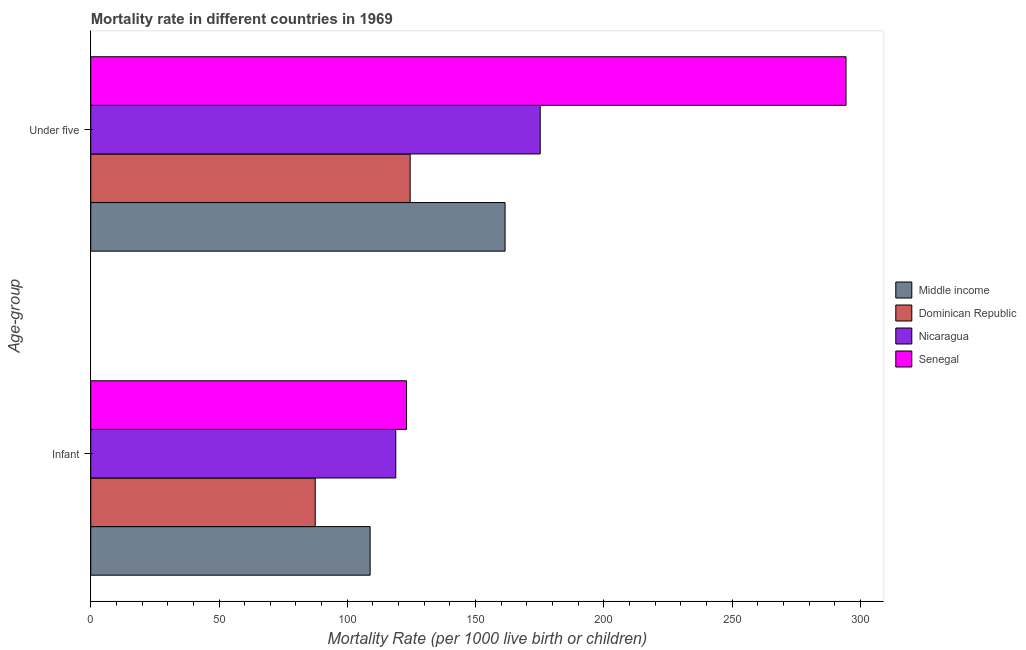How many different coloured bars are there?
Provide a succinct answer. 4. Are the number of bars per tick equal to the number of legend labels?
Make the answer very short. Yes. How many bars are there on the 2nd tick from the top?
Your answer should be compact. 4. What is the label of the 2nd group of bars from the top?
Your answer should be compact. Infant. What is the infant mortality rate in Dominican Republic?
Ensure brevity in your answer.  87.5. Across all countries, what is the maximum under-5 mortality rate?
Your response must be concise. 294.4. Across all countries, what is the minimum under-5 mortality rate?
Your answer should be very brief. 124.5. In which country was the infant mortality rate maximum?
Offer a terse response. Senegal. In which country was the infant mortality rate minimum?
Ensure brevity in your answer.  Dominican Republic. What is the total under-5 mortality rate in the graph?
Ensure brevity in your answer.  755.6. What is the difference between the under-5 mortality rate in Middle income and that in Senegal?
Keep it short and to the point. -132.9. What is the difference between the infant mortality rate in Senegal and the under-5 mortality rate in Middle income?
Your answer should be very brief. -38.4. What is the average infant mortality rate per country?
Make the answer very short. 109.6. What is the difference between the infant mortality rate and under-5 mortality rate in Senegal?
Give a very brief answer. -171.3. What is the ratio of the under-5 mortality rate in Middle income to that in Senegal?
Provide a succinct answer. 0.55. Is the infant mortality rate in Senegal less than that in Middle income?
Provide a short and direct response. No. In how many countries, is the under-5 mortality rate greater than the average under-5 mortality rate taken over all countries?
Make the answer very short. 1. What does the 2nd bar from the top in Infant represents?
Offer a terse response. Nicaragua. What does the 1st bar from the bottom in Infant represents?
Give a very brief answer. Middle income. How many countries are there in the graph?
Keep it short and to the point. 4. Does the graph contain any zero values?
Give a very brief answer. No. Does the graph contain grids?
Provide a short and direct response. No. Where does the legend appear in the graph?
Keep it short and to the point. Center right. How are the legend labels stacked?
Your response must be concise. Vertical. What is the title of the graph?
Make the answer very short. Mortality rate in different countries in 1969. What is the label or title of the X-axis?
Give a very brief answer. Mortality Rate (per 1000 live birth or children). What is the label or title of the Y-axis?
Provide a short and direct response. Age-group. What is the Mortality Rate (per 1000 live birth or children) of Middle income in Infant?
Your answer should be compact. 108.9. What is the Mortality Rate (per 1000 live birth or children) in Dominican Republic in Infant?
Give a very brief answer. 87.5. What is the Mortality Rate (per 1000 live birth or children) of Nicaragua in Infant?
Your answer should be compact. 118.9. What is the Mortality Rate (per 1000 live birth or children) of Senegal in Infant?
Your answer should be very brief. 123.1. What is the Mortality Rate (per 1000 live birth or children) of Middle income in Under five?
Keep it short and to the point. 161.5. What is the Mortality Rate (per 1000 live birth or children) of Dominican Republic in Under five?
Provide a succinct answer. 124.5. What is the Mortality Rate (per 1000 live birth or children) in Nicaragua in Under five?
Make the answer very short. 175.2. What is the Mortality Rate (per 1000 live birth or children) in Senegal in Under five?
Make the answer very short. 294.4. Across all Age-group, what is the maximum Mortality Rate (per 1000 live birth or children) in Middle income?
Offer a very short reply. 161.5. Across all Age-group, what is the maximum Mortality Rate (per 1000 live birth or children) in Dominican Republic?
Ensure brevity in your answer.  124.5. Across all Age-group, what is the maximum Mortality Rate (per 1000 live birth or children) in Nicaragua?
Ensure brevity in your answer.  175.2. Across all Age-group, what is the maximum Mortality Rate (per 1000 live birth or children) in Senegal?
Provide a short and direct response. 294.4. Across all Age-group, what is the minimum Mortality Rate (per 1000 live birth or children) in Middle income?
Your response must be concise. 108.9. Across all Age-group, what is the minimum Mortality Rate (per 1000 live birth or children) in Dominican Republic?
Your response must be concise. 87.5. Across all Age-group, what is the minimum Mortality Rate (per 1000 live birth or children) in Nicaragua?
Your answer should be compact. 118.9. Across all Age-group, what is the minimum Mortality Rate (per 1000 live birth or children) in Senegal?
Keep it short and to the point. 123.1. What is the total Mortality Rate (per 1000 live birth or children) in Middle income in the graph?
Your answer should be very brief. 270.4. What is the total Mortality Rate (per 1000 live birth or children) of Dominican Republic in the graph?
Make the answer very short. 212. What is the total Mortality Rate (per 1000 live birth or children) of Nicaragua in the graph?
Offer a very short reply. 294.1. What is the total Mortality Rate (per 1000 live birth or children) of Senegal in the graph?
Your answer should be compact. 417.5. What is the difference between the Mortality Rate (per 1000 live birth or children) of Middle income in Infant and that in Under five?
Your answer should be compact. -52.6. What is the difference between the Mortality Rate (per 1000 live birth or children) in Dominican Republic in Infant and that in Under five?
Your answer should be compact. -37. What is the difference between the Mortality Rate (per 1000 live birth or children) of Nicaragua in Infant and that in Under five?
Your answer should be very brief. -56.3. What is the difference between the Mortality Rate (per 1000 live birth or children) of Senegal in Infant and that in Under five?
Provide a succinct answer. -171.3. What is the difference between the Mortality Rate (per 1000 live birth or children) of Middle income in Infant and the Mortality Rate (per 1000 live birth or children) of Dominican Republic in Under five?
Ensure brevity in your answer.  -15.6. What is the difference between the Mortality Rate (per 1000 live birth or children) in Middle income in Infant and the Mortality Rate (per 1000 live birth or children) in Nicaragua in Under five?
Your answer should be compact. -66.3. What is the difference between the Mortality Rate (per 1000 live birth or children) of Middle income in Infant and the Mortality Rate (per 1000 live birth or children) of Senegal in Under five?
Offer a terse response. -185.5. What is the difference between the Mortality Rate (per 1000 live birth or children) in Dominican Republic in Infant and the Mortality Rate (per 1000 live birth or children) in Nicaragua in Under five?
Your answer should be compact. -87.7. What is the difference between the Mortality Rate (per 1000 live birth or children) in Dominican Republic in Infant and the Mortality Rate (per 1000 live birth or children) in Senegal in Under five?
Your answer should be compact. -206.9. What is the difference between the Mortality Rate (per 1000 live birth or children) of Nicaragua in Infant and the Mortality Rate (per 1000 live birth or children) of Senegal in Under five?
Your answer should be compact. -175.5. What is the average Mortality Rate (per 1000 live birth or children) of Middle income per Age-group?
Offer a terse response. 135.2. What is the average Mortality Rate (per 1000 live birth or children) in Dominican Republic per Age-group?
Provide a short and direct response. 106. What is the average Mortality Rate (per 1000 live birth or children) in Nicaragua per Age-group?
Your response must be concise. 147.05. What is the average Mortality Rate (per 1000 live birth or children) in Senegal per Age-group?
Make the answer very short. 208.75. What is the difference between the Mortality Rate (per 1000 live birth or children) in Middle income and Mortality Rate (per 1000 live birth or children) in Dominican Republic in Infant?
Provide a short and direct response. 21.4. What is the difference between the Mortality Rate (per 1000 live birth or children) of Middle income and Mortality Rate (per 1000 live birth or children) of Nicaragua in Infant?
Give a very brief answer. -10. What is the difference between the Mortality Rate (per 1000 live birth or children) of Dominican Republic and Mortality Rate (per 1000 live birth or children) of Nicaragua in Infant?
Offer a very short reply. -31.4. What is the difference between the Mortality Rate (per 1000 live birth or children) of Dominican Republic and Mortality Rate (per 1000 live birth or children) of Senegal in Infant?
Provide a short and direct response. -35.6. What is the difference between the Mortality Rate (per 1000 live birth or children) of Middle income and Mortality Rate (per 1000 live birth or children) of Nicaragua in Under five?
Give a very brief answer. -13.7. What is the difference between the Mortality Rate (per 1000 live birth or children) of Middle income and Mortality Rate (per 1000 live birth or children) of Senegal in Under five?
Your response must be concise. -132.9. What is the difference between the Mortality Rate (per 1000 live birth or children) of Dominican Republic and Mortality Rate (per 1000 live birth or children) of Nicaragua in Under five?
Ensure brevity in your answer.  -50.7. What is the difference between the Mortality Rate (per 1000 live birth or children) in Dominican Republic and Mortality Rate (per 1000 live birth or children) in Senegal in Under five?
Your response must be concise. -169.9. What is the difference between the Mortality Rate (per 1000 live birth or children) in Nicaragua and Mortality Rate (per 1000 live birth or children) in Senegal in Under five?
Provide a short and direct response. -119.2. What is the ratio of the Mortality Rate (per 1000 live birth or children) of Middle income in Infant to that in Under five?
Offer a terse response. 0.67. What is the ratio of the Mortality Rate (per 1000 live birth or children) of Dominican Republic in Infant to that in Under five?
Your response must be concise. 0.7. What is the ratio of the Mortality Rate (per 1000 live birth or children) of Nicaragua in Infant to that in Under five?
Give a very brief answer. 0.68. What is the ratio of the Mortality Rate (per 1000 live birth or children) of Senegal in Infant to that in Under five?
Provide a short and direct response. 0.42. What is the difference between the highest and the second highest Mortality Rate (per 1000 live birth or children) of Middle income?
Make the answer very short. 52.6. What is the difference between the highest and the second highest Mortality Rate (per 1000 live birth or children) in Dominican Republic?
Offer a terse response. 37. What is the difference between the highest and the second highest Mortality Rate (per 1000 live birth or children) of Nicaragua?
Your answer should be compact. 56.3. What is the difference between the highest and the second highest Mortality Rate (per 1000 live birth or children) in Senegal?
Give a very brief answer. 171.3. What is the difference between the highest and the lowest Mortality Rate (per 1000 live birth or children) in Middle income?
Offer a very short reply. 52.6. What is the difference between the highest and the lowest Mortality Rate (per 1000 live birth or children) in Nicaragua?
Ensure brevity in your answer.  56.3. What is the difference between the highest and the lowest Mortality Rate (per 1000 live birth or children) in Senegal?
Offer a very short reply. 171.3. 